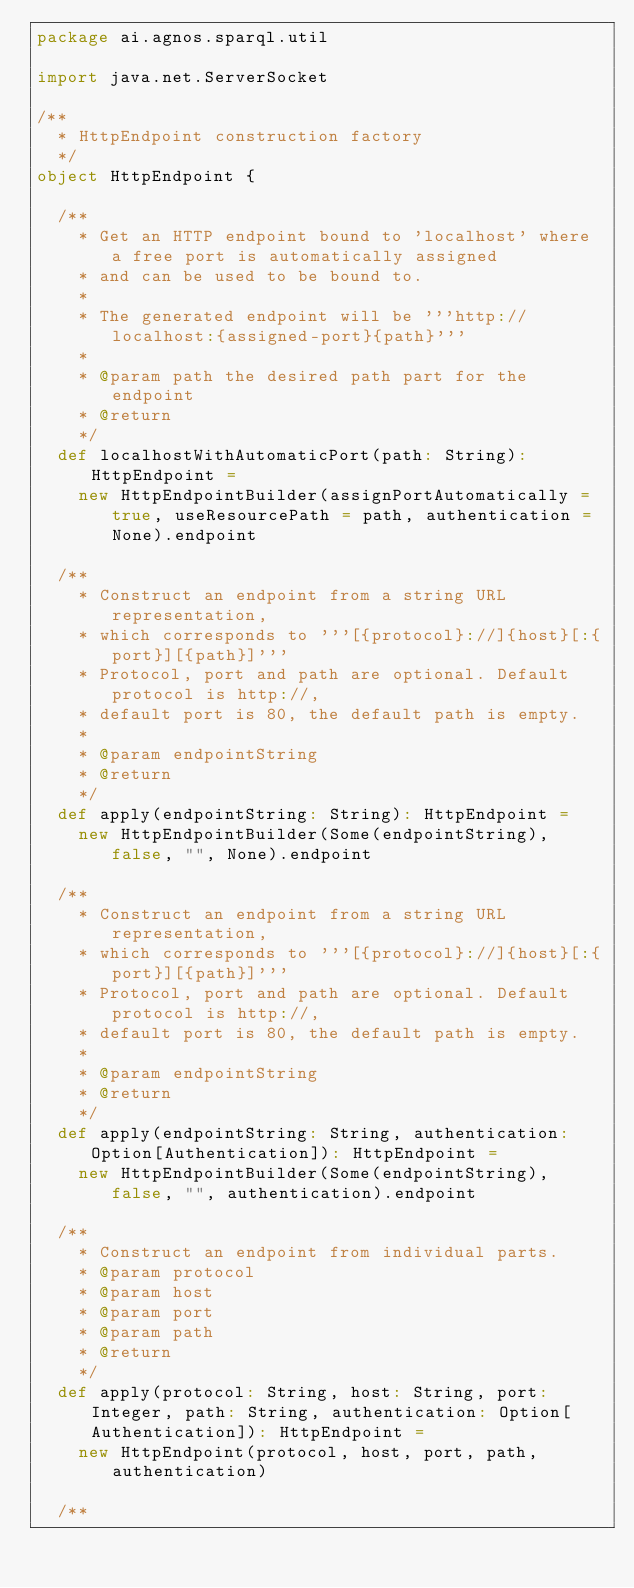Convert code to text. <code><loc_0><loc_0><loc_500><loc_500><_Scala_>package ai.agnos.sparql.util

import java.net.ServerSocket

/**
  * HttpEndpoint construction factory
  */
object HttpEndpoint {

  /**
    * Get an HTTP endpoint bound to 'localhost' where a free port is automatically assigned
    * and can be used to be bound to.
    *
    * The generated endpoint will be '''http://localhost:{assigned-port}{path}'''
    *
    * @param path the desired path part for the endpoint
    * @return
    */
  def localhostWithAutomaticPort(path: String): HttpEndpoint =
    new HttpEndpointBuilder(assignPortAutomatically = true, useResourcePath = path, authentication = None).endpoint

  /**
    * Construct an endpoint from a string URL representation,
    * which corresponds to '''[{protocol}://]{host}[:{port}][{path}]'''
    * Protocol, port and path are optional. Default protocol is http://,
    * default port is 80, the default path is empty.
    *
    * @param endpointString
    * @return
    */
  def apply(endpointString: String): HttpEndpoint =
    new HttpEndpointBuilder(Some(endpointString), false, "", None).endpoint

  /**
    * Construct an endpoint from a string URL representation,
    * which corresponds to '''[{protocol}://]{host}[:{port}][{path}]'''
    * Protocol, port and path are optional. Default protocol is http://,
    * default port is 80, the default path is empty.
    *
    * @param endpointString
    * @return
    */
  def apply(endpointString: String, authentication: Option[Authentication]): HttpEndpoint =
    new HttpEndpointBuilder(Some(endpointString), false, "", authentication).endpoint

  /**
    * Construct an endpoint from individual parts.
    * @param protocol
    * @param host
    * @param port
    * @param path
    * @return
    */
  def apply(protocol: String, host: String, port: Integer, path: String, authentication: Option[Authentication]): HttpEndpoint =
    new HttpEndpoint(protocol, host, port, path, authentication)

  /**</code> 